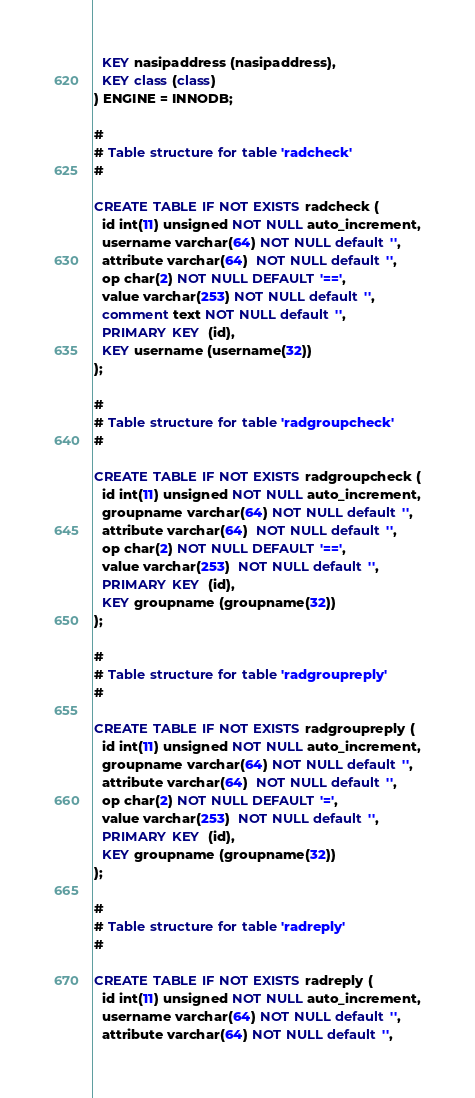Convert code to text. <code><loc_0><loc_0><loc_500><loc_500><_SQL_>  KEY nasipaddress (nasipaddress),
  KEY class (class)
) ENGINE = INNODB;

#
# Table structure for table 'radcheck'
#

CREATE TABLE IF NOT EXISTS radcheck (
  id int(11) unsigned NOT NULL auto_increment,
  username varchar(64) NOT NULL default '',
  attribute varchar(64)  NOT NULL default '',
  op char(2) NOT NULL DEFAULT '==',
  value varchar(253) NOT NULL default '',
  comment text NOT NULL default '',
  PRIMARY KEY  (id),
  KEY username (username(32))
);

#
# Table structure for table 'radgroupcheck'
#

CREATE TABLE IF NOT EXISTS radgroupcheck (
  id int(11) unsigned NOT NULL auto_increment,
  groupname varchar(64) NOT NULL default '',
  attribute varchar(64)  NOT NULL default '',
  op char(2) NOT NULL DEFAULT '==',
  value varchar(253)  NOT NULL default '',
  PRIMARY KEY  (id),
  KEY groupname (groupname(32))
);

#
# Table structure for table 'radgroupreply'
#

CREATE TABLE IF NOT EXISTS radgroupreply (
  id int(11) unsigned NOT NULL auto_increment,
  groupname varchar(64) NOT NULL default '',
  attribute varchar(64)  NOT NULL default '',
  op char(2) NOT NULL DEFAULT '=',
  value varchar(253)  NOT NULL default '',
  PRIMARY KEY  (id),
  KEY groupname (groupname(32))
);

#
# Table structure for table 'radreply'
#

CREATE TABLE IF NOT EXISTS radreply (
  id int(11) unsigned NOT NULL auto_increment,
  username varchar(64) NOT NULL default '',
  attribute varchar(64) NOT NULL default '',</code> 